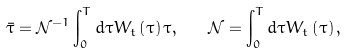Convert formula to latex. <formula><loc_0><loc_0><loc_500><loc_500>\bar { \tau } = \mathcal { N } ^ { - 1 } \int _ { 0 } ^ { T } d \tau W _ { t } \left ( \tau \right ) \tau , \quad \mathcal { N } = \int _ { 0 } ^ { T } d \tau W _ { t } \left ( \tau \right ) ,</formula> 